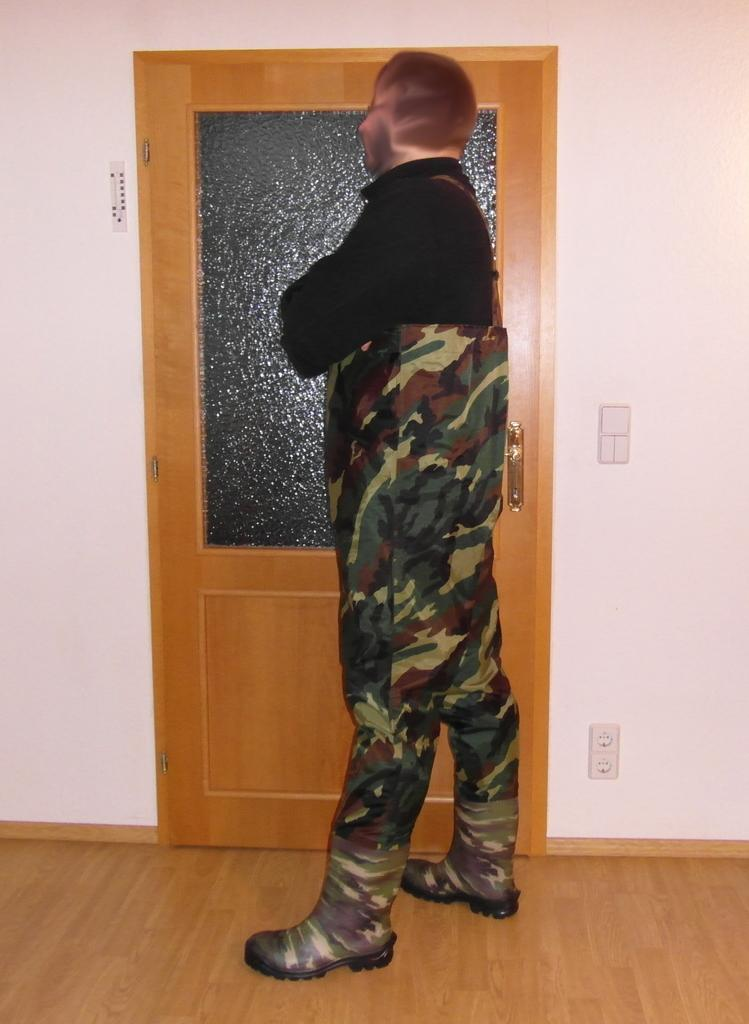Who is present in the image? There is a man in the image. What is the man's position in the image? The man is standing on the floor. In which direction is the man facing? The man is facing towards the left side. What can be seen in the background of the image? There is a door and a wall in the background of the image. How many sheep are visible in the image? There are no sheep present in the image. What type of bag is the man carrying in the image? The man is not carrying a bag in the image. 